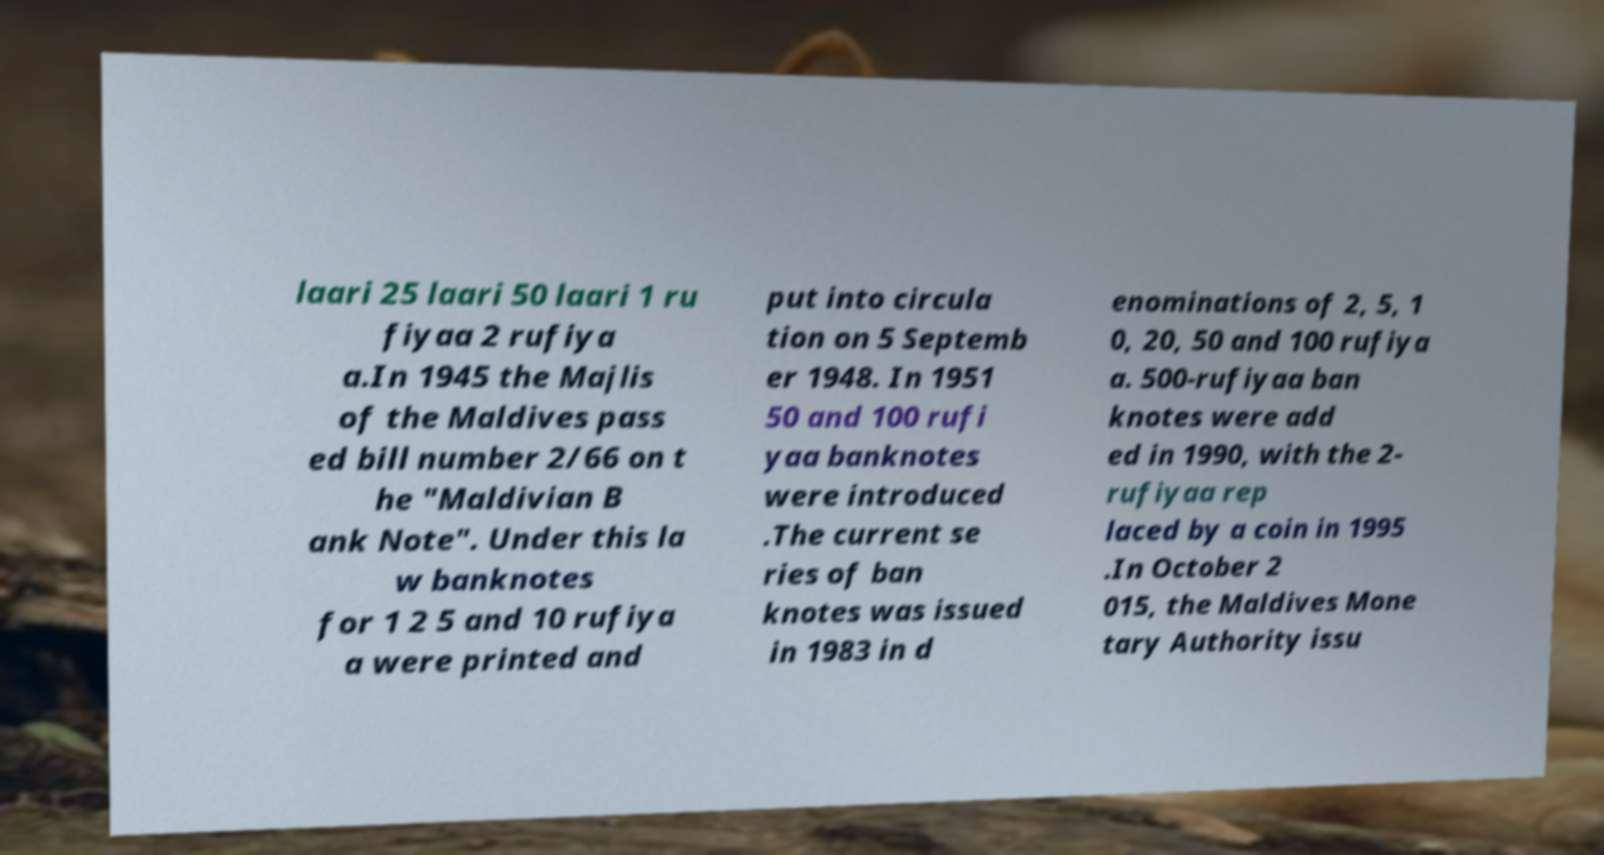For documentation purposes, I need the text within this image transcribed. Could you provide that? laari 25 laari 50 laari 1 ru fiyaa 2 rufiya a.In 1945 the Majlis of the Maldives pass ed bill number 2/66 on t he "Maldivian B ank Note". Under this la w banknotes for 1 2 5 and 10 rufiya a were printed and put into circula tion on 5 Septemb er 1948. In 1951 50 and 100 rufi yaa banknotes were introduced .The current se ries of ban knotes was issued in 1983 in d enominations of 2, 5, 1 0, 20, 50 and 100 rufiya a. 500-rufiyaa ban knotes were add ed in 1990, with the 2- rufiyaa rep laced by a coin in 1995 .In October 2 015, the Maldives Mone tary Authority issu 